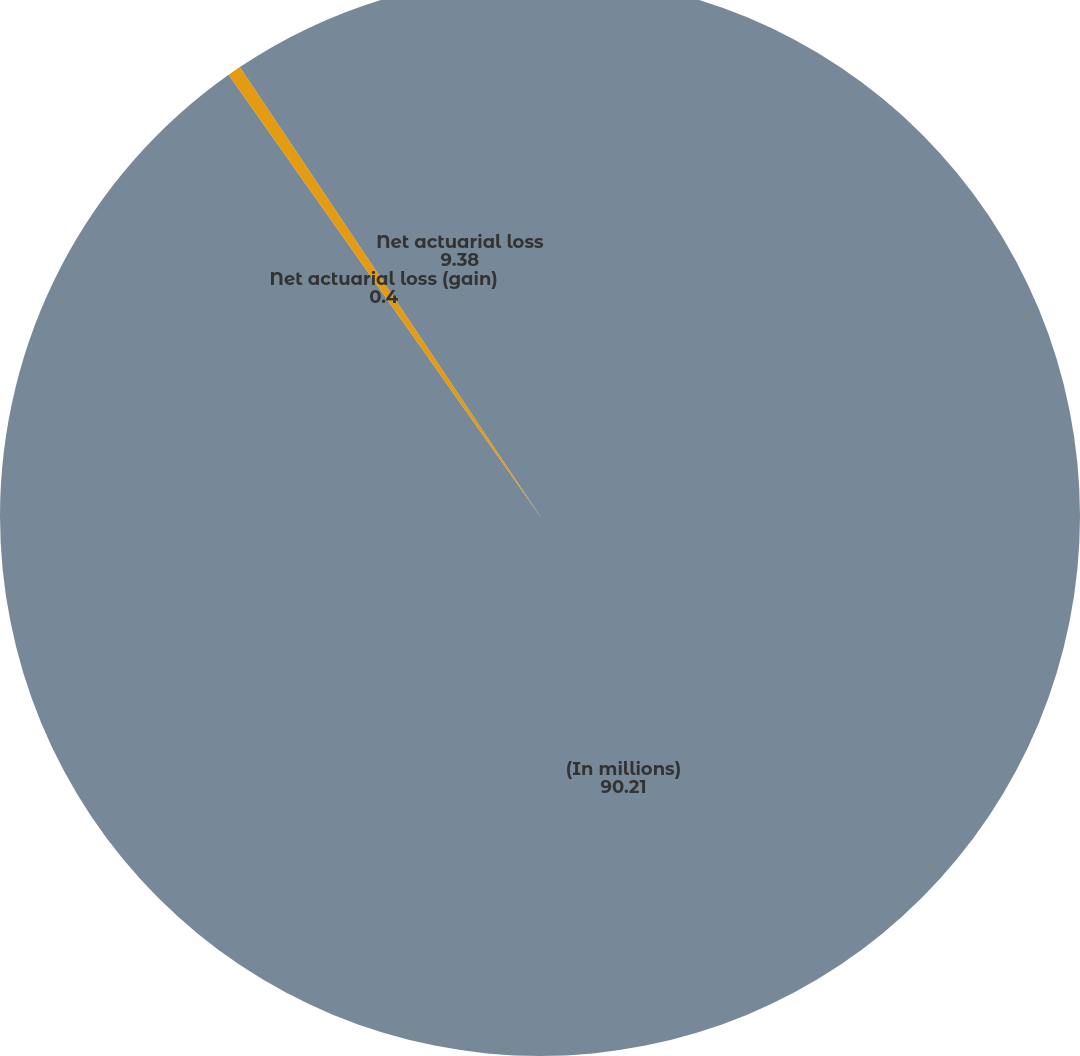Convert chart. <chart><loc_0><loc_0><loc_500><loc_500><pie_chart><fcel>(In millions)<fcel>Net actuarial loss (gain)<fcel>Net actuarial loss<nl><fcel>90.21%<fcel>0.4%<fcel>9.38%<nl></chart> 